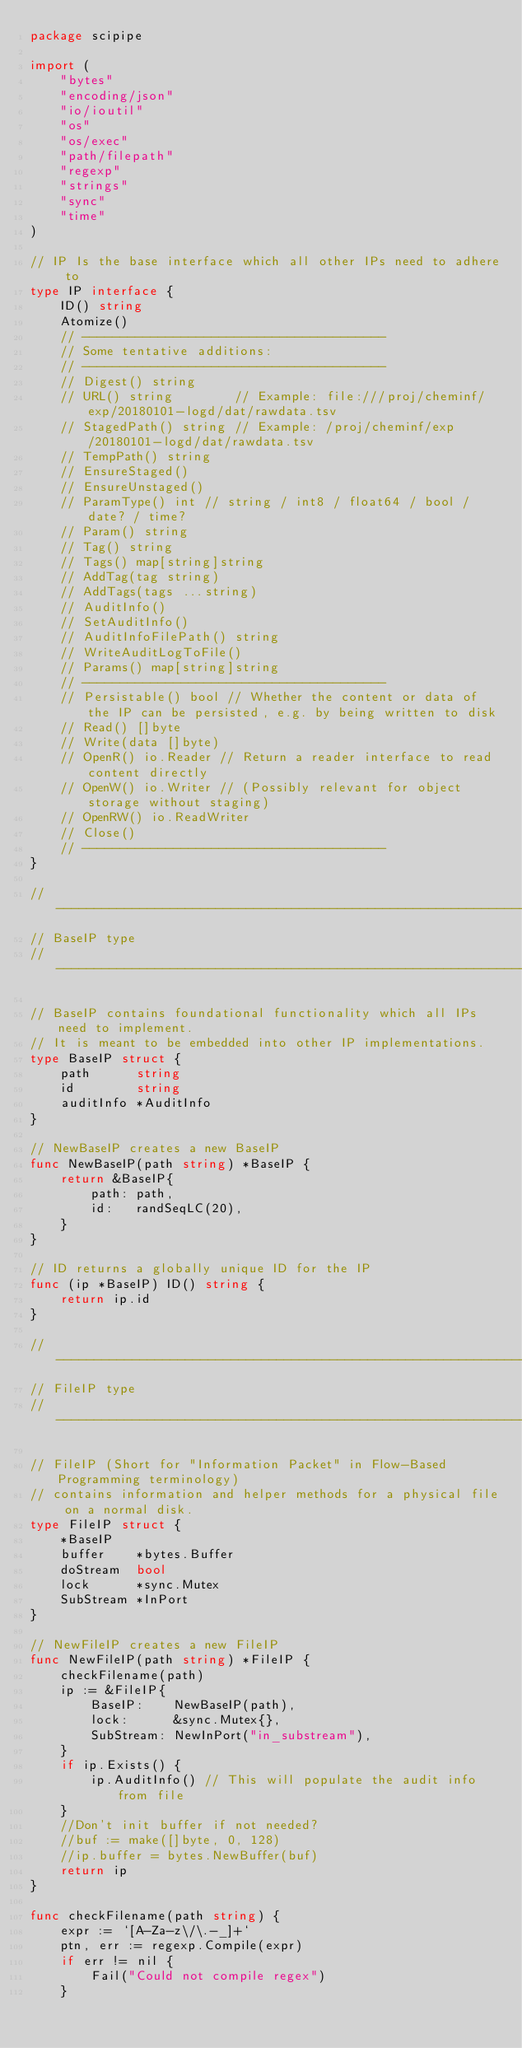<code> <loc_0><loc_0><loc_500><loc_500><_Go_>package scipipe

import (
	"bytes"
	"encoding/json"
	"io/ioutil"
	"os"
	"os/exec"
	"path/filepath"
	"regexp"
	"strings"
	"sync"
	"time"
)

// IP Is the base interface which all other IPs need to adhere to
type IP interface {
	ID() string
	Atomize()
	// ----------------------------------------
	// Some tentative additions:
	// ----------------------------------------
	// Digest() string
	// URL() string        // Example: file:///proj/cheminf/exp/20180101-logd/dat/rawdata.tsv
	// StagedPath() string // Example: /proj/cheminf/exp/20180101-logd/dat/rawdata.tsv
	// TempPath() string
	// EnsureStaged()
	// EnsureUnstaged()
	// ParamType() int // string / int8 / float64 / bool / date? / time?
	// Param() string
	// Tag() string
	// Tags() map[string]string
	// AddTag(tag string)
	// AddTags(tags ...string)
	// AuditInfo()
	// SetAuditInfo()
	// AuditInfoFilePath() string
	// WriteAuditLogToFile()
	// Params() map[string]string
	// ----------------------------------------
	// Persistable() bool // Whether the content or data of the IP can be persisted, e.g. by being written to disk
	// Read() []byte
	// Write(data []byte)
	// OpenR() io.Reader // Return a reader interface to read content directly
	// OpenW() io.Writer // (Possibly relevant for object storage without staging)
	// OpenRW() io.ReadWriter
	// Close()
	// ----------------------------------------
}

// ------------------------------------------------------------------------
// BaseIP type
// ------------------------------------------------------------------------

// BaseIP contains foundational functionality which all IPs need to implement.
// It is meant to be embedded into other IP implementations.
type BaseIP struct {
	path      string
	id        string
	auditInfo *AuditInfo
}

// NewBaseIP creates a new BaseIP
func NewBaseIP(path string) *BaseIP {
	return &BaseIP{
		path: path,
		id:   randSeqLC(20),
	}
}

// ID returns a globally unique ID for the IP
func (ip *BaseIP) ID() string {
	return ip.id
}

// ------------------------------------------------------------------------
// FileIP type
// ------------------------------------------------------------------------

// FileIP (Short for "Information Packet" in Flow-Based Programming terminology)
// contains information and helper methods for a physical file on a normal disk.
type FileIP struct {
	*BaseIP
	buffer    *bytes.Buffer
	doStream  bool
	lock      *sync.Mutex
	SubStream *InPort
}

// NewFileIP creates a new FileIP
func NewFileIP(path string) *FileIP {
	checkFilename(path)
	ip := &FileIP{
		BaseIP:    NewBaseIP(path),
		lock:      &sync.Mutex{},
		SubStream: NewInPort("in_substream"),
	}
	if ip.Exists() {
		ip.AuditInfo() // This will populate the audit info from file
	}
	//Don't init buffer if not needed?
	//buf := make([]byte, 0, 128)
	//ip.buffer = bytes.NewBuffer(buf)
	return ip
}

func checkFilename(path string) {
	expr := `[A-Za-z\/\.-_]+`
	ptn, err := regexp.Compile(expr)
	if err != nil {
		Fail("Could not compile regex")
	}</code> 